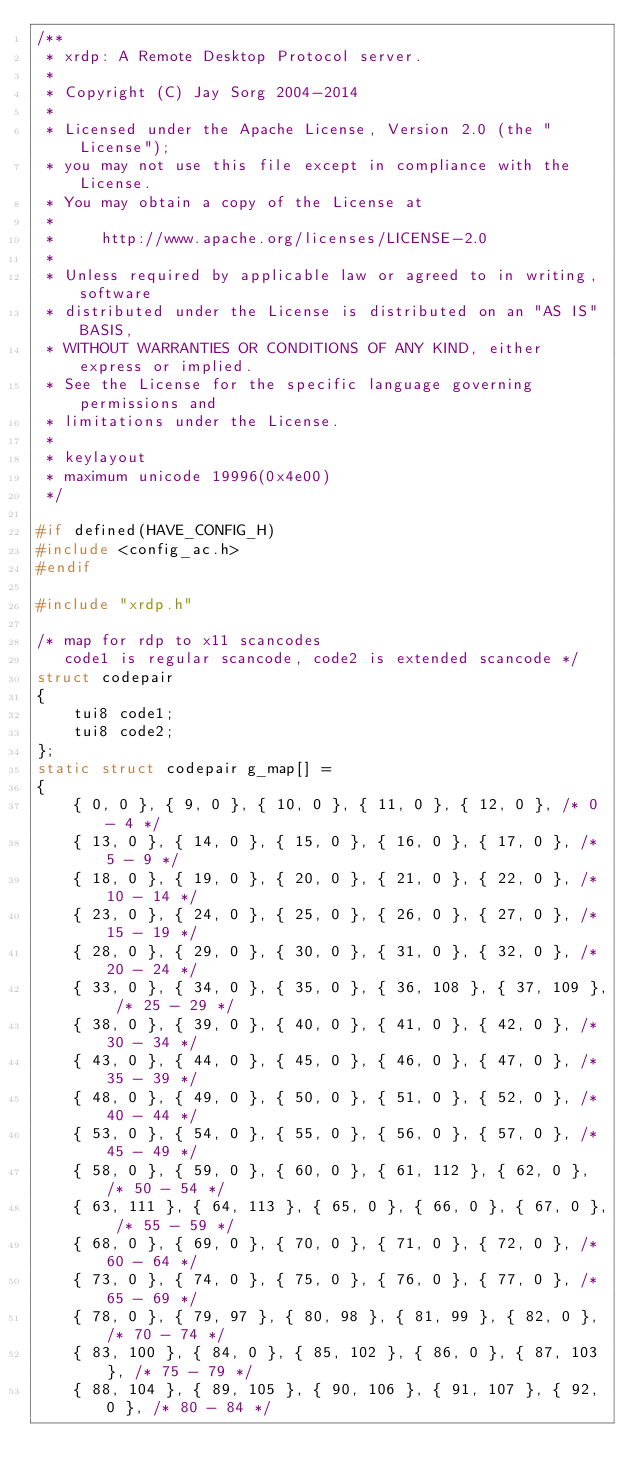Convert code to text. <code><loc_0><loc_0><loc_500><loc_500><_C_>/**
 * xrdp: A Remote Desktop Protocol server.
 *
 * Copyright (C) Jay Sorg 2004-2014
 *
 * Licensed under the Apache License, Version 2.0 (the "License");
 * you may not use this file except in compliance with the License.
 * You may obtain a copy of the License at
 *
 *     http://www.apache.org/licenses/LICENSE-2.0
 *
 * Unless required by applicable law or agreed to in writing, software
 * distributed under the License is distributed on an "AS IS" BASIS,
 * WITHOUT WARRANTIES OR CONDITIONS OF ANY KIND, either express or implied.
 * See the License for the specific language governing permissions and
 * limitations under the License.
 *
 * keylayout
 * maximum unicode 19996(0x4e00)
 */

#if defined(HAVE_CONFIG_H)
#include <config_ac.h>
#endif

#include "xrdp.h"

/* map for rdp to x11 scancodes
   code1 is regular scancode, code2 is extended scancode */
struct codepair
{
    tui8 code1;
    tui8 code2;
};
static struct codepair g_map[] =
{
    { 0, 0 }, { 9, 0 }, { 10, 0 }, { 11, 0 }, { 12, 0 }, /* 0 - 4 */
    { 13, 0 }, { 14, 0 }, { 15, 0 }, { 16, 0 }, { 17, 0 }, /* 5 - 9 */
    { 18, 0 }, { 19, 0 }, { 20, 0 }, { 21, 0 }, { 22, 0 }, /* 10 - 14 */
    { 23, 0 }, { 24, 0 }, { 25, 0 }, { 26, 0 }, { 27, 0 }, /* 15 - 19 */
    { 28, 0 }, { 29, 0 }, { 30, 0 }, { 31, 0 }, { 32, 0 }, /* 20 - 24 */
    { 33, 0 }, { 34, 0 }, { 35, 0 }, { 36, 108 }, { 37, 109 }, /* 25 - 29 */
    { 38, 0 }, { 39, 0 }, { 40, 0 }, { 41, 0 }, { 42, 0 }, /* 30 - 34 */
    { 43, 0 }, { 44, 0 }, { 45, 0 }, { 46, 0 }, { 47, 0 }, /* 35 - 39 */
    { 48, 0 }, { 49, 0 }, { 50, 0 }, { 51, 0 }, { 52, 0 }, /* 40 - 44 */
    { 53, 0 }, { 54, 0 }, { 55, 0 }, { 56, 0 }, { 57, 0 }, /* 45 - 49 */
    { 58, 0 }, { 59, 0 }, { 60, 0 }, { 61, 112 }, { 62, 0 }, /* 50 - 54 */
    { 63, 111 }, { 64, 113 }, { 65, 0 }, { 66, 0 }, { 67, 0 }, /* 55 - 59 */
    { 68, 0 }, { 69, 0 }, { 70, 0 }, { 71, 0 }, { 72, 0 }, /* 60 - 64 */
    { 73, 0 }, { 74, 0 }, { 75, 0 }, { 76, 0 }, { 77, 0 }, /* 65 - 69 */
    { 78, 0 }, { 79, 97 }, { 80, 98 }, { 81, 99 }, { 82, 0 }, /* 70 - 74 */
    { 83, 100 }, { 84, 0 }, { 85, 102 }, { 86, 0 }, { 87, 103 }, /* 75 - 79 */
    { 88, 104 }, { 89, 105 }, { 90, 106 }, { 91, 107 }, { 92, 0 }, /* 80 - 84 */</code> 